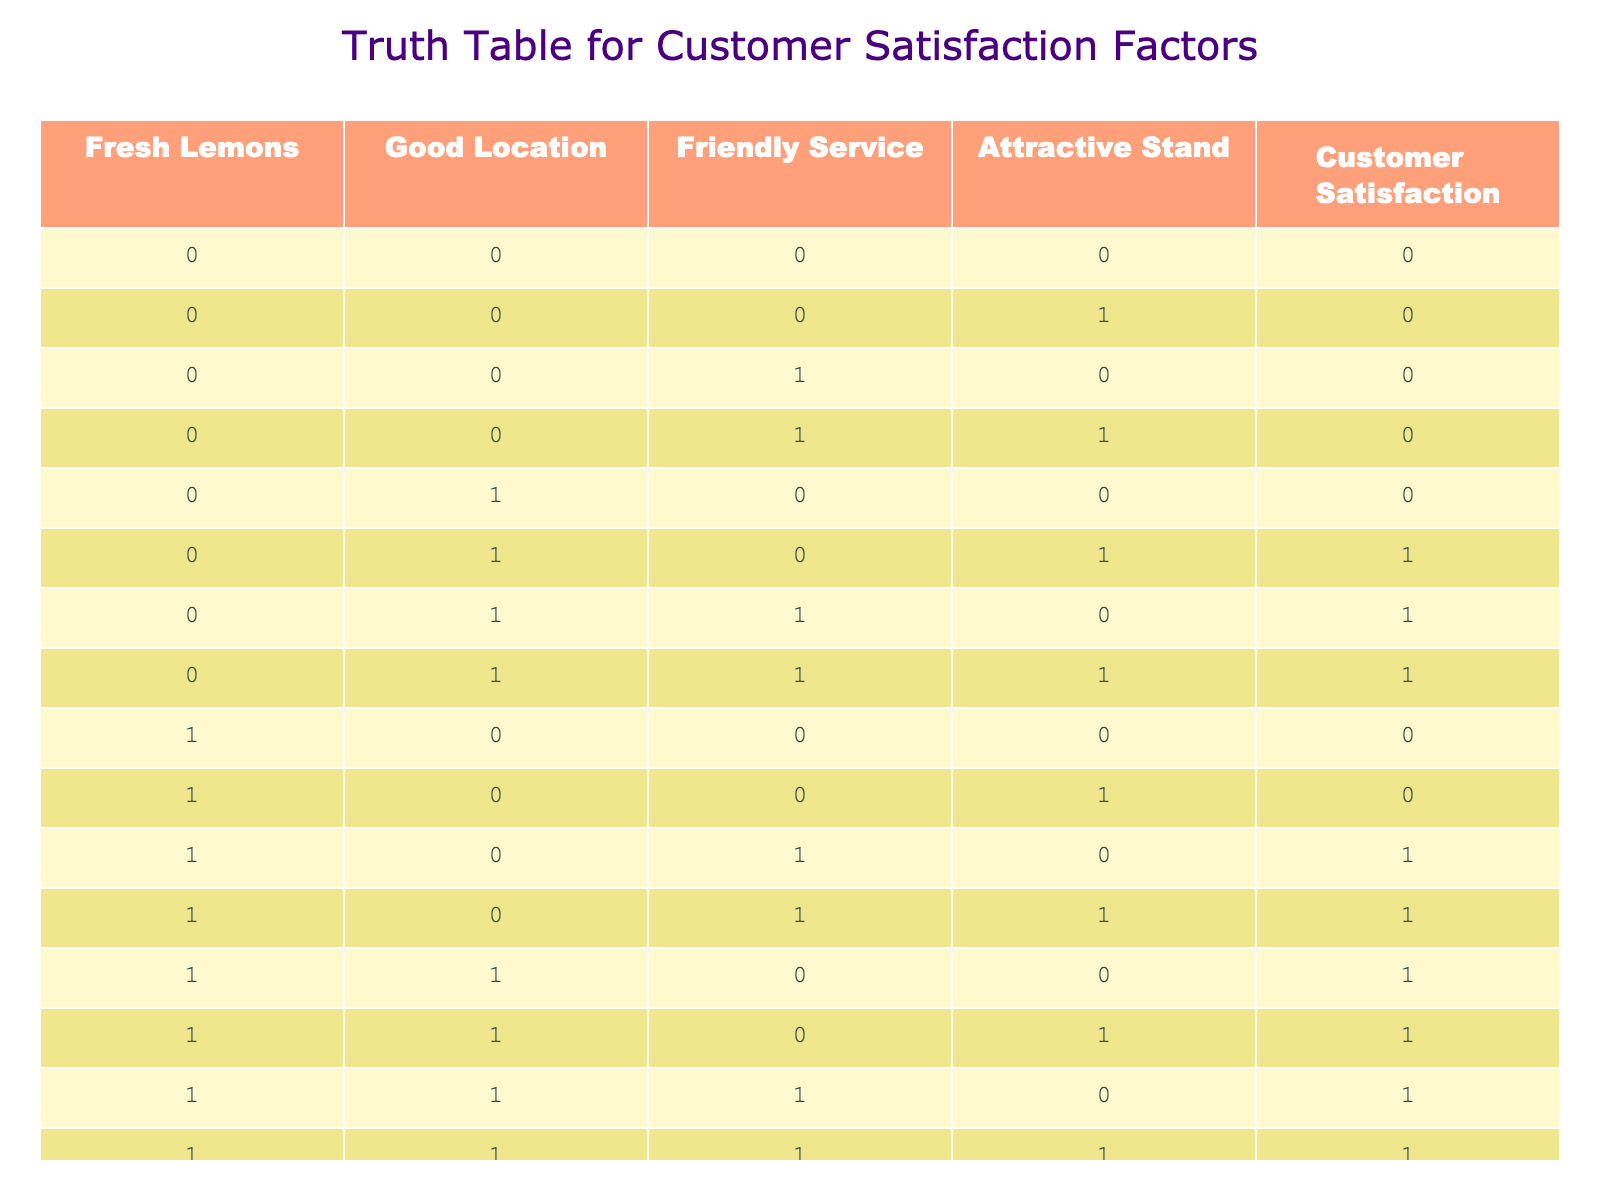What is the customer satisfaction rating when fresh lemons are used and the stand is attractive? In the table, we can locate the row where fresh lemons are set to 1 and the attractive stand is also set to 1. The corresponding customer satisfaction rating for this combination is 1.
Answer: 1 How many combinations have good location and friendly service that resulted in customer satisfaction? To find this, we need to look for rows where both good location and friendly service are set to 1. In the table, there are three rows (0, 1, 1 and 1, 1, 0) that fulfill this condition, and each shows a customer satisfaction of 1. Therefore, the total count of combinations is 2.
Answer: 2 Is it true that customer satisfaction is always 1 if the stand is attractive? We examine all rows where the attractive stand is 1. There are a total of eight instances of the attractive stand being 1. Among these, the customer satisfaction is 1 in seven out of the eight cases. Therefore, it is not always true as there is one case with customer satisfaction 0.
Answer: No What is the average customer satisfaction rating when both friendly service and fresh lemons are available? We find the rows where both friendly service and fresh lemons are set to 1 to compute the average. These rows are (1, 1, 1, 1) and (1, 1, 0, 1), both with customer satisfaction of 1. Thus, the average is (1 + 1) / 2 = 1.
Answer: 1 How does the customer satisfaction change if we only consider cases with a good location? We identify the rows where good location is set to 1. Evaluating these rows results in four total instances with customer satisfaction ratings of 1, 1, 0, and 1. Counting only the satisfied ratings gives us a total of 3 out of 4, so the satisfaction remains relatively high.
Answer: 3 out of 4 What is the number of cases where customer satisfaction equals 0? We can count the rows where the customer satisfaction column has a value of 0. There are a total of six rows exhibiting this rating, which indicates the number of combinations that failed to satisfy customers.
Answer: 6 How many unique combinations lead to customer satisfaction when using fresh lemons? To assess this, we count the rows possessing fresh lemons (when set to 1) and check their customer satisfaction rating. Among the eight rows with fresh lemons, customer satisfaction is 1 for six cases. Thus, the total number of unique satisfying combinations is 6.
Answer: 6 What specific combination of factors resulted in customer satisfaction to be 0? Reviewing the rows where customer satisfaction is set to 0, we find the following combinations: (0, 0, 0, 0), (0, 0, 0, 1), (0, 0, 1, 0), (0, 1, 0, 0), and (1, 0, 0, 0). These combinations all failed to satisfy customers.
Answer: 5 combinations 